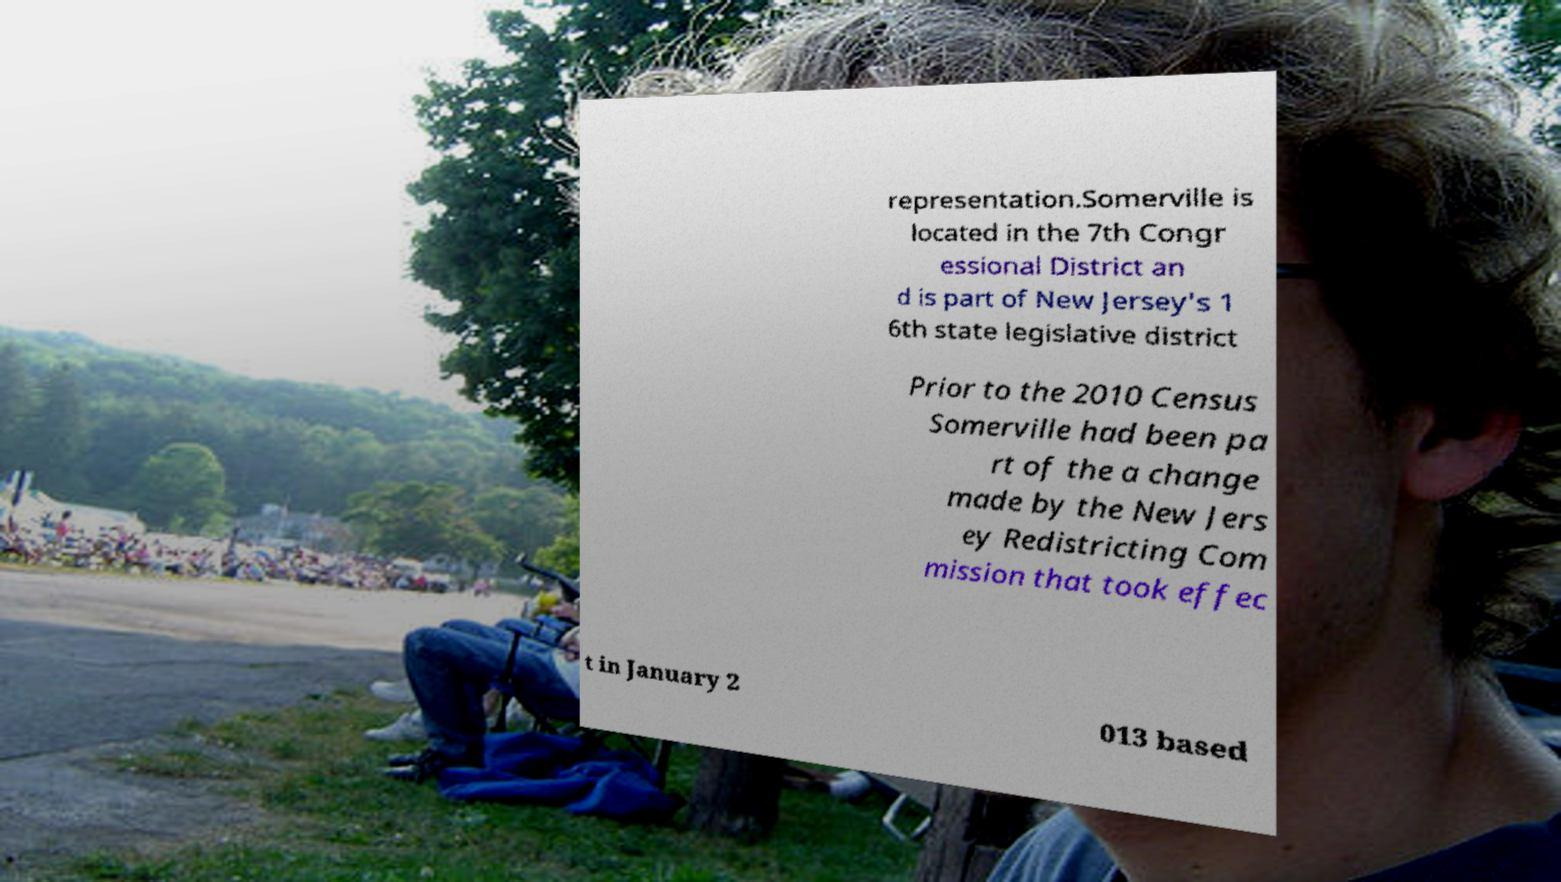Can you read and provide the text displayed in the image?This photo seems to have some interesting text. Can you extract and type it out for me? representation.Somerville is located in the 7th Congr essional District an d is part of New Jersey's 1 6th state legislative district Prior to the 2010 Census Somerville had been pa rt of the a change made by the New Jers ey Redistricting Com mission that took effec t in January 2 013 based 